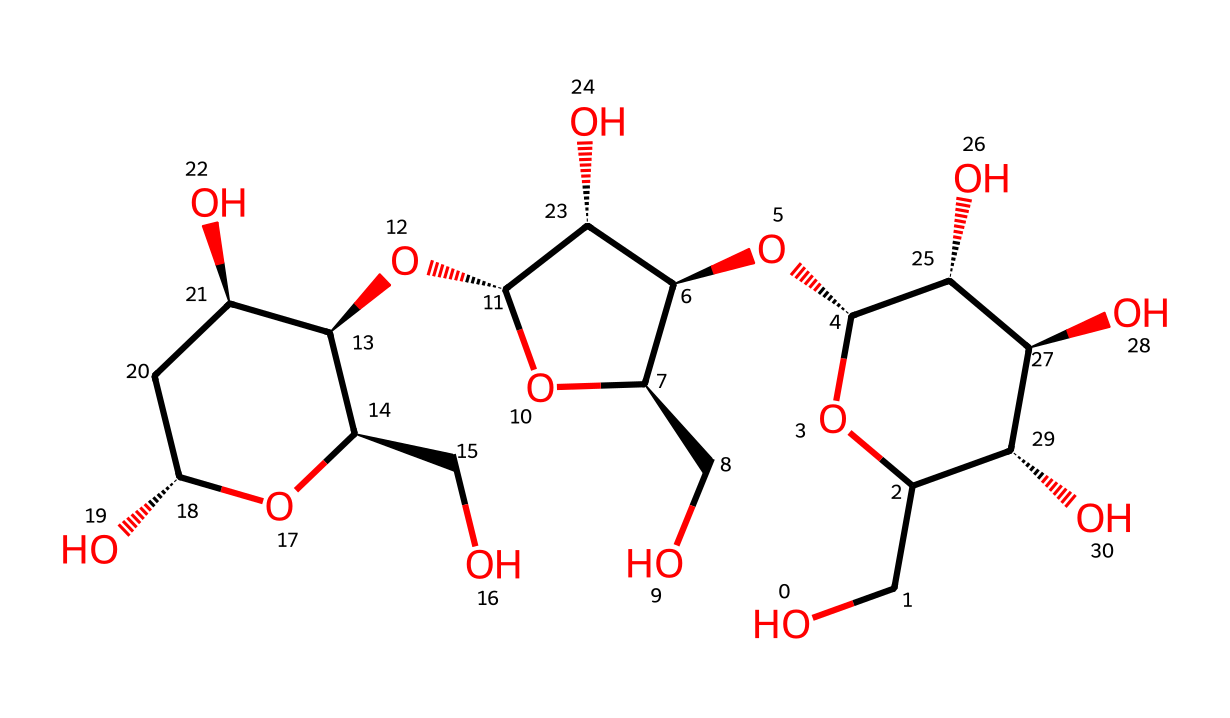What is the molecular formula of cellulose? To determine the molecular formula, we analyze the structure represented by the SMILES, which shows interconnected rings and hydroxyl groups. Counting the carbon (C), hydrogen (H), and oxygen (O) atoms gives us C6H10O5 as the empirical formula for one repeating unit of cellulose.
Answer: C6H10O5 How many hydroxyl groups are present in this chemical structure? By examining the structure, we can identify each hydroxyl (-OH) group attached to the carbon rings. There are a total of five hydroxyl groups observable within the chemical structure.
Answer: five How many carbon atoms are connected in the repeating unit of cellulose? The structure consists of a series of glucose units linked by glycosidic bonds. Each glucose unit contains six carbon atoms, and in the repeating unit depicted, there are six carbon atoms forming the main backbone.
Answer: six What type of carbohydrate is cellulose classified as? Cellulose is classified as a polysaccharide due to its formation from multiple monosaccharide units (glucose). The complexity of its structure, consisting of long chains of glucose molecules, distinctly categorizes it as a polysaccharide.
Answer: polysaccharide What is the primary structural feature that makes cellulose a strong material for paper? The extensive hydrogen bonding among cellulose fibers provides tensile strength and stability, crucial for the structural integrity of paper. This is a result of the hydroxyl groups interacting across multiple cellulose molecules.
Answer: hydrogen bonding What type of linkage connects glucose units in cellulose? The glucose units in cellulose are linked by beta-1,4-glycosidic linkages, which contributes to its linear chains and unique properties. This specific configuration provides cellulose with rigidity and insolubility.
Answer: beta-1,4-glycosidic linkage 